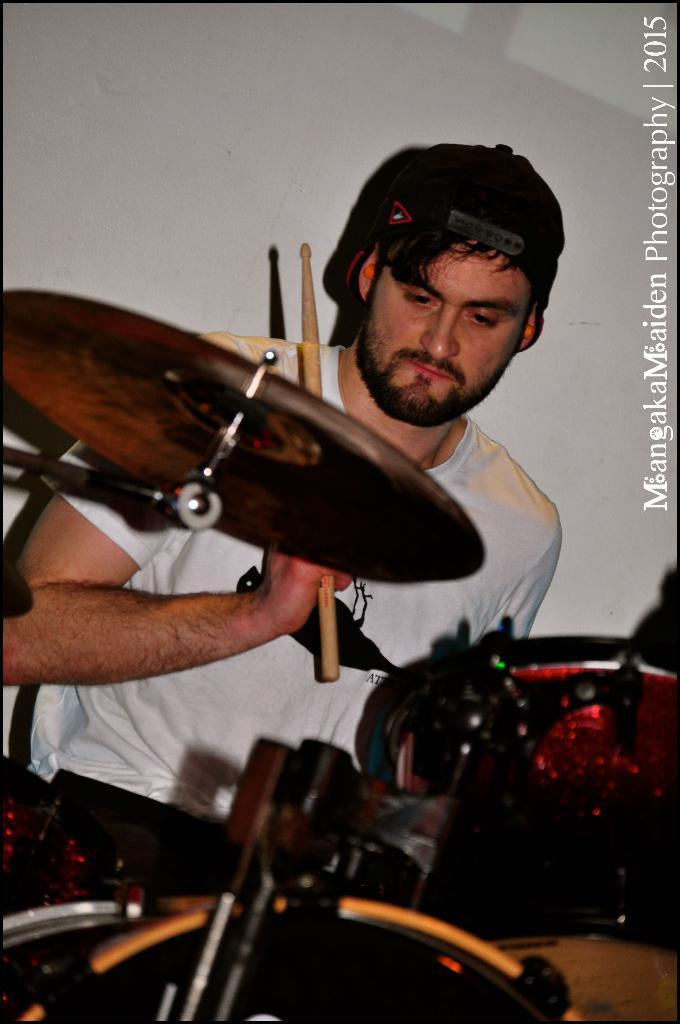Who is present in the image? There is a man in the image. What is the man holding in the image? The man is holding sticks. What object is in front of the man? There is a musical instrument in front of the man. What is the weight of the effect the man is creating with the sticks? There is no mention of an effect or weight in the image, as it only shows a man holding sticks and a musical instrument in front of him. 